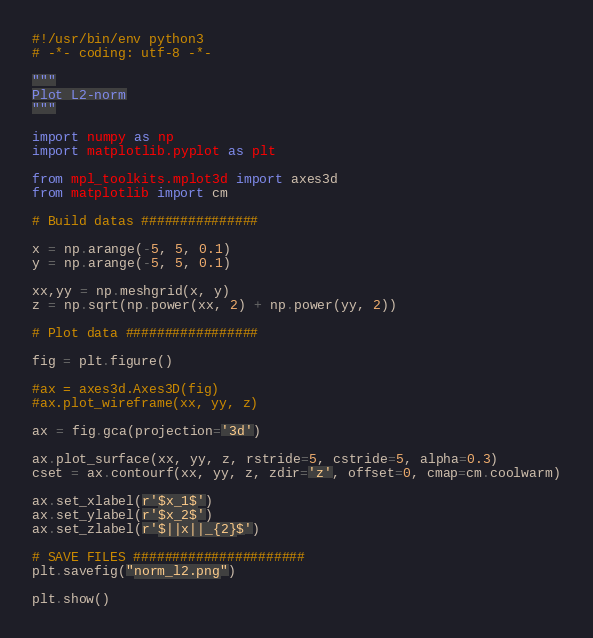Convert code to text. <code><loc_0><loc_0><loc_500><loc_500><_Python_>#!/usr/bin/env python3
# -*- coding: utf-8 -*-

"""
Plot L2-norm
"""

import numpy as np
import matplotlib.pyplot as plt

from mpl_toolkits.mplot3d import axes3d
from matplotlib import cm

# Build datas ###############

x = np.arange(-5, 5, 0.1)
y = np.arange(-5, 5, 0.1)

xx,yy = np.meshgrid(x, y)
z = np.sqrt(np.power(xx, 2) + np.power(yy, 2))

# Plot data #################

fig = plt.figure()

#ax = axes3d.Axes3D(fig)
#ax.plot_wireframe(xx, yy, z)

ax = fig.gca(projection='3d')

ax.plot_surface(xx, yy, z, rstride=5, cstride=5, alpha=0.3)
cset = ax.contourf(xx, yy, z, zdir='z', offset=0, cmap=cm.coolwarm)

ax.set_xlabel(r'$x_1$')
ax.set_ylabel(r'$x_2$')
ax.set_zlabel(r'$||x||_{2}$')

# SAVE FILES ######################
plt.savefig("norm_l2.png")

plt.show()

</code> 